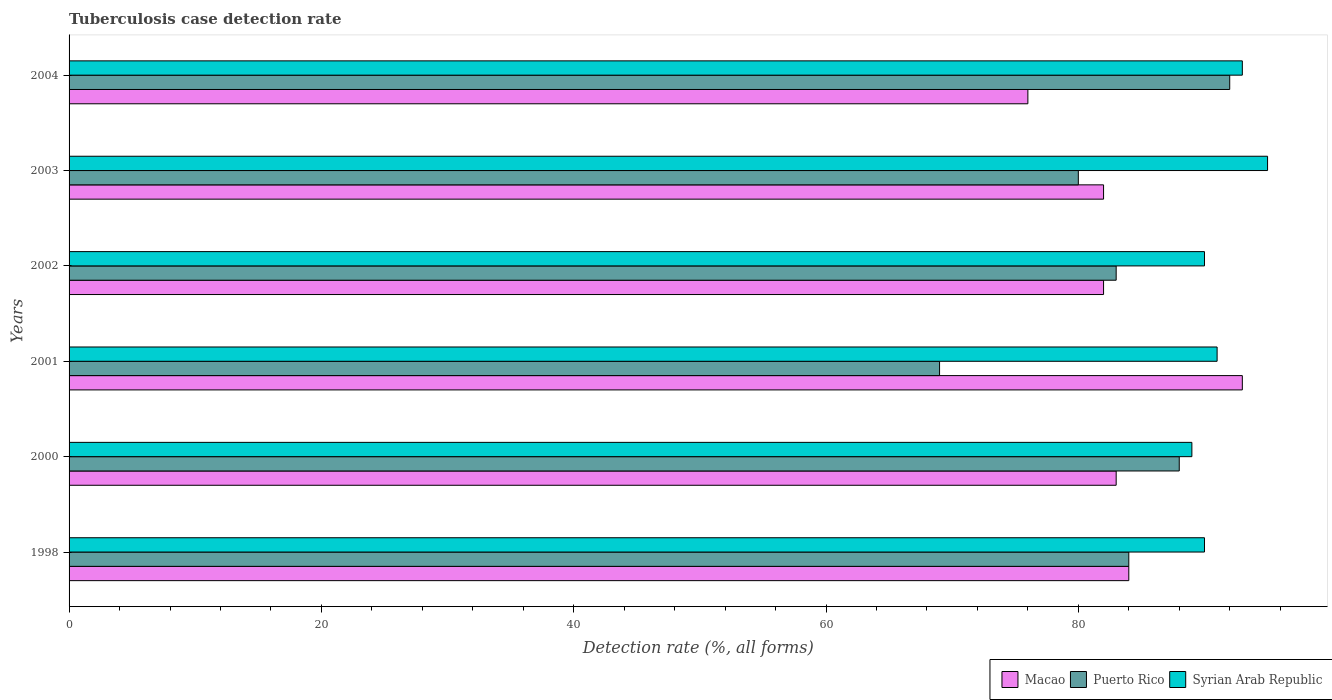How many different coloured bars are there?
Offer a very short reply. 3. How many groups of bars are there?
Give a very brief answer. 6. Are the number of bars per tick equal to the number of legend labels?
Offer a very short reply. Yes. How many bars are there on the 3rd tick from the top?
Your answer should be very brief. 3. In how many cases, is the number of bars for a given year not equal to the number of legend labels?
Your answer should be very brief. 0. What is the tuberculosis case detection rate in in Puerto Rico in 2000?
Your answer should be compact. 88. Across all years, what is the maximum tuberculosis case detection rate in in Macao?
Give a very brief answer. 93. In which year was the tuberculosis case detection rate in in Puerto Rico maximum?
Your answer should be very brief. 2004. In which year was the tuberculosis case detection rate in in Syrian Arab Republic minimum?
Ensure brevity in your answer.  2000. What is the total tuberculosis case detection rate in in Syrian Arab Republic in the graph?
Give a very brief answer. 548. What is the difference between the tuberculosis case detection rate in in Macao in 1998 and that in 2001?
Provide a short and direct response. -9. What is the difference between the tuberculosis case detection rate in in Macao in 2004 and the tuberculosis case detection rate in in Syrian Arab Republic in 2003?
Your answer should be very brief. -19. What is the average tuberculosis case detection rate in in Macao per year?
Provide a short and direct response. 83.33. In the year 2001, what is the difference between the tuberculosis case detection rate in in Puerto Rico and tuberculosis case detection rate in in Macao?
Offer a terse response. -24. What is the ratio of the tuberculosis case detection rate in in Macao in 1998 to that in 2002?
Keep it short and to the point. 1.02. Is the difference between the tuberculosis case detection rate in in Puerto Rico in 2000 and 2004 greater than the difference between the tuberculosis case detection rate in in Macao in 2000 and 2004?
Provide a short and direct response. No. What is the difference between the highest and the lowest tuberculosis case detection rate in in Syrian Arab Republic?
Offer a terse response. 6. What does the 1st bar from the top in 2004 represents?
Offer a terse response. Syrian Arab Republic. What does the 3rd bar from the bottom in 2003 represents?
Your answer should be very brief. Syrian Arab Republic. Are all the bars in the graph horizontal?
Ensure brevity in your answer.  Yes. How many years are there in the graph?
Provide a short and direct response. 6. Where does the legend appear in the graph?
Provide a short and direct response. Bottom right. How many legend labels are there?
Keep it short and to the point. 3. What is the title of the graph?
Provide a succinct answer. Tuberculosis case detection rate. Does "El Salvador" appear as one of the legend labels in the graph?
Ensure brevity in your answer.  No. What is the label or title of the X-axis?
Keep it short and to the point. Detection rate (%, all forms). What is the label or title of the Y-axis?
Make the answer very short. Years. What is the Detection rate (%, all forms) in Syrian Arab Republic in 2000?
Ensure brevity in your answer.  89. What is the Detection rate (%, all forms) of Macao in 2001?
Your answer should be compact. 93. What is the Detection rate (%, all forms) in Syrian Arab Republic in 2001?
Provide a short and direct response. 91. What is the Detection rate (%, all forms) in Syrian Arab Republic in 2002?
Your response must be concise. 90. What is the Detection rate (%, all forms) of Syrian Arab Republic in 2003?
Provide a short and direct response. 95. What is the Detection rate (%, all forms) of Puerto Rico in 2004?
Offer a terse response. 92. What is the Detection rate (%, all forms) of Syrian Arab Republic in 2004?
Ensure brevity in your answer.  93. Across all years, what is the maximum Detection rate (%, all forms) in Macao?
Provide a succinct answer. 93. Across all years, what is the maximum Detection rate (%, all forms) of Puerto Rico?
Keep it short and to the point. 92. Across all years, what is the maximum Detection rate (%, all forms) of Syrian Arab Republic?
Offer a terse response. 95. Across all years, what is the minimum Detection rate (%, all forms) in Syrian Arab Republic?
Your response must be concise. 89. What is the total Detection rate (%, all forms) of Macao in the graph?
Ensure brevity in your answer.  500. What is the total Detection rate (%, all forms) of Puerto Rico in the graph?
Make the answer very short. 496. What is the total Detection rate (%, all forms) of Syrian Arab Republic in the graph?
Provide a succinct answer. 548. What is the difference between the Detection rate (%, all forms) in Macao in 1998 and that in 2000?
Your response must be concise. 1. What is the difference between the Detection rate (%, all forms) in Puerto Rico in 1998 and that in 2000?
Offer a terse response. -4. What is the difference between the Detection rate (%, all forms) in Syrian Arab Republic in 1998 and that in 2000?
Provide a short and direct response. 1. What is the difference between the Detection rate (%, all forms) of Puerto Rico in 1998 and that in 2002?
Offer a terse response. 1. What is the difference between the Detection rate (%, all forms) of Puerto Rico in 1998 and that in 2003?
Make the answer very short. 4. What is the difference between the Detection rate (%, all forms) of Macao in 1998 and that in 2004?
Make the answer very short. 8. What is the difference between the Detection rate (%, all forms) in Syrian Arab Republic in 1998 and that in 2004?
Make the answer very short. -3. What is the difference between the Detection rate (%, all forms) of Macao in 2000 and that in 2001?
Make the answer very short. -10. What is the difference between the Detection rate (%, all forms) of Syrian Arab Republic in 2000 and that in 2001?
Your answer should be compact. -2. What is the difference between the Detection rate (%, all forms) in Macao in 2000 and that in 2002?
Give a very brief answer. 1. What is the difference between the Detection rate (%, all forms) in Puerto Rico in 2000 and that in 2002?
Provide a succinct answer. 5. What is the difference between the Detection rate (%, all forms) of Macao in 2000 and that in 2003?
Offer a very short reply. 1. What is the difference between the Detection rate (%, all forms) in Macao in 2000 and that in 2004?
Make the answer very short. 7. What is the difference between the Detection rate (%, all forms) in Syrian Arab Republic in 2000 and that in 2004?
Make the answer very short. -4. What is the difference between the Detection rate (%, all forms) of Macao in 2001 and that in 2002?
Make the answer very short. 11. What is the difference between the Detection rate (%, all forms) in Puerto Rico in 2001 and that in 2002?
Your answer should be very brief. -14. What is the difference between the Detection rate (%, all forms) of Macao in 2001 and that in 2003?
Ensure brevity in your answer.  11. What is the difference between the Detection rate (%, all forms) in Puerto Rico in 2001 and that in 2003?
Ensure brevity in your answer.  -11. What is the difference between the Detection rate (%, all forms) in Syrian Arab Republic in 2001 and that in 2003?
Make the answer very short. -4. What is the difference between the Detection rate (%, all forms) of Macao in 2001 and that in 2004?
Give a very brief answer. 17. What is the difference between the Detection rate (%, all forms) in Puerto Rico in 2001 and that in 2004?
Your answer should be compact. -23. What is the difference between the Detection rate (%, all forms) in Macao in 2002 and that in 2003?
Give a very brief answer. 0. What is the difference between the Detection rate (%, all forms) in Syrian Arab Republic in 2002 and that in 2003?
Your response must be concise. -5. What is the difference between the Detection rate (%, all forms) in Macao in 2002 and that in 2004?
Your response must be concise. 6. What is the difference between the Detection rate (%, all forms) of Puerto Rico in 2002 and that in 2004?
Make the answer very short. -9. What is the difference between the Detection rate (%, all forms) of Macao in 2003 and that in 2004?
Offer a very short reply. 6. What is the difference between the Detection rate (%, all forms) in Syrian Arab Republic in 2003 and that in 2004?
Your answer should be very brief. 2. What is the difference between the Detection rate (%, all forms) of Macao in 1998 and the Detection rate (%, all forms) of Syrian Arab Republic in 2000?
Your response must be concise. -5. What is the difference between the Detection rate (%, all forms) in Macao in 1998 and the Detection rate (%, all forms) in Puerto Rico in 2001?
Keep it short and to the point. 15. What is the difference between the Detection rate (%, all forms) of Macao in 1998 and the Detection rate (%, all forms) of Syrian Arab Republic in 2001?
Offer a very short reply. -7. What is the difference between the Detection rate (%, all forms) in Puerto Rico in 1998 and the Detection rate (%, all forms) in Syrian Arab Republic in 2001?
Ensure brevity in your answer.  -7. What is the difference between the Detection rate (%, all forms) in Macao in 1998 and the Detection rate (%, all forms) in Syrian Arab Republic in 2002?
Provide a succinct answer. -6. What is the difference between the Detection rate (%, all forms) of Macao in 1998 and the Detection rate (%, all forms) of Puerto Rico in 2003?
Offer a very short reply. 4. What is the difference between the Detection rate (%, all forms) of Macao in 1998 and the Detection rate (%, all forms) of Syrian Arab Republic in 2003?
Offer a very short reply. -11. What is the difference between the Detection rate (%, all forms) of Puerto Rico in 1998 and the Detection rate (%, all forms) of Syrian Arab Republic in 2003?
Your answer should be compact. -11. What is the difference between the Detection rate (%, all forms) in Macao in 1998 and the Detection rate (%, all forms) in Puerto Rico in 2004?
Your answer should be very brief. -8. What is the difference between the Detection rate (%, all forms) of Macao in 1998 and the Detection rate (%, all forms) of Syrian Arab Republic in 2004?
Provide a short and direct response. -9. What is the difference between the Detection rate (%, all forms) in Puerto Rico in 1998 and the Detection rate (%, all forms) in Syrian Arab Republic in 2004?
Offer a very short reply. -9. What is the difference between the Detection rate (%, all forms) in Macao in 2000 and the Detection rate (%, all forms) in Syrian Arab Republic in 2001?
Provide a short and direct response. -8. What is the difference between the Detection rate (%, all forms) in Macao in 2000 and the Detection rate (%, all forms) in Syrian Arab Republic in 2003?
Make the answer very short. -12. What is the difference between the Detection rate (%, all forms) in Macao in 2000 and the Detection rate (%, all forms) in Syrian Arab Republic in 2004?
Offer a terse response. -10. What is the difference between the Detection rate (%, all forms) of Puerto Rico in 2000 and the Detection rate (%, all forms) of Syrian Arab Republic in 2004?
Ensure brevity in your answer.  -5. What is the difference between the Detection rate (%, all forms) in Macao in 2001 and the Detection rate (%, all forms) in Syrian Arab Republic in 2003?
Ensure brevity in your answer.  -2. What is the difference between the Detection rate (%, all forms) in Puerto Rico in 2001 and the Detection rate (%, all forms) in Syrian Arab Republic in 2003?
Provide a succinct answer. -26. What is the difference between the Detection rate (%, all forms) in Macao in 2001 and the Detection rate (%, all forms) in Syrian Arab Republic in 2004?
Provide a short and direct response. 0. What is the difference between the Detection rate (%, all forms) in Macao in 2002 and the Detection rate (%, all forms) in Syrian Arab Republic in 2003?
Offer a terse response. -13. What is the difference between the Detection rate (%, all forms) in Macao in 2002 and the Detection rate (%, all forms) in Puerto Rico in 2004?
Give a very brief answer. -10. What is the difference between the Detection rate (%, all forms) of Macao in 2002 and the Detection rate (%, all forms) of Syrian Arab Republic in 2004?
Offer a terse response. -11. What is the difference between the Detection rate (%, all forms) of Puerto Rico in 2002 and the Detection rate (%, all forms) of Syrian Arab Republic in 2004?
Ensure brevity in your answer.  -10. What is the difference between the Detection rate (%, all forms) of Macao in 2003 and the Detection rate (%, all forms) of Syrian Arab Republic in 2004?
Provide a short and direct response. -11. What is the difference between the Detection rate (%, all forms) of Puerto Rico in 2003 and the Detection rate (%, all forms) of Syrian Arab Republic in 2004?
Give a very brief answer. -13. What is the average Detection rate (%, all forms) in Macao per year?
Provide a succinct answer. 83.33. What is the average Detection rate (%, all forms) of Puerto Rico per year?
Provide a succinct answer. 82.67. What is the average Detection rate (%, all forms) of Syrian Arab Republic per year?
Your answer should be very brief. 91.33. In the year 1998, what is the difference between the Detection rate (%, all forms) in Macao and Detection rate (%, all forms) in Puerto Rico?
Give a very brief answer. 0. In the year 1998, what is the difference between the Detection rate (%, all forms) of Macao and Detection rate (%, all forms) of Syrian Arab Republic?
Your answer should be very brief. -6. In the year 1998, what is the difference between the Detection rate (%, all forms) in Puerto Rico and Detection rate (%, all forms) in Syrian Arab Republic?
Your answer should be very brief. -6. In the year 2000, what is the difference between the Detection rate (%, all forms) in Macao and Detection rate (%, all forms) in Puerto Rico?
Your answer should be compact. -5. In the year 2000, what is the difference between the Detection rate (%, all forms) of Macao and Detection rate (%, all forms) of Syrian Arab Republic?
Your response must be concise. -6. In the year 2002, what is the difference between the Detection rate (%, all forms) of Puerto Rico and Detection rate (%, all forms) of Syrian Arab Republic?
Provide a succinct answer. -7. In the year 2003, what is the difference between the Detection rate (%, all forms) of Macao and Detection rate (%, all forms) of Syrian Arab Republic?
Provide a succinct answer. -13. In the year 2004, what is the difference between the Detection rate (%, all forms) in Macao and Detection rate (%, all forms) in Puerto Rico?
Provide a short and direct response. -16. In the year 2004, what is the difference between the Detection rate (%, all forms) in Macao and Detection rate (%, all forms) in Syrian Arab Republic?
Ensure brevity in your answer.  -17. In the year 2004, what is the difference between the Detection rate (%, all forms) of Puerto Rico and Detection rate (%, all forms) of Syrian Arab Republic?
Your answer should be compact. -1. What is the ratio of the Detection rate (%, all forms) in Macao in 1998 to that in 2000?
Your answer should be very brief. 1.01. What is the ratio of the Detection rate (%, all forms) in Puerto Rico in 1998 to that in 2000?
Give a very brief answer. 0.95. What is the ratio of the Detection rate (%, all forms) of Syrian Arab Republic in 1998 to that in 2000?
Your answer should be very brief. 1.01. What is the ratio of the Detection rate (%, all forms) in Macao in 1998 to that in 2001?
Make the answer very short. 0.9. What is the ratio of the Detection rate (%, all forms) in Puerto Rico in 1998 to that in 2001?
Your response must be concise. 1.22. What is the ratio of the Detection rate (%, all forms) in Macao in 1998 to that in 2002?
Make the answer very short. 1.02. What is the ratio of the Detection rate (%, all forms) of Macao in 1998 to that in 2003?
Provide a succinct answer. 1.02. What is the ratio of the Detection rate (%, all forms) in Puerto Rico in 1998 to that in 2003?
Offer a very short reply. 1.05. What is the ratio of the Detection rate (%, all forms) of Syrian Arab Republic in 1998 to that in 2003?
Your answer should be very brief. 0.95. What is the ratio of the Detection rate (%, all forms) in Macao in 1998 to that in 2004?
Your answer should be compact. 1.11. What is the ratio of the Detection rate (%, all forms) of Syrian Arab Republic in 1998 to that in 2004?
Your response must be concise. 0.97. What is the ratio of the Detection rate (%, all forms) in Macao in 2000 to that in 2001?
Provide a succinct answer. 0.89. What is the ratio of the Detection rate (%, all forms) of Puerto Rico in 2000 to that in 2001?
Your answer should be very brief. 1.28. What is the ratio of the Detection rate (%, all forms) in Syrian Arab Republic in 2000 to that in 2001?
Your answer should be compact. 0.98. What is the ratio of the Detection rate (%, all forms) of Macao in 2000 to that in 2002?
Offer a very short reply. 1.01. What is the ratio of the Detection rate (%, all forms) in Puerto Rico in 2000 to that in 2002?
Make the answer very short. 1.06. What is the ratio of the Detection rate (%, all forms) of Syrian Arab Republic in 2000 to that in 2002?
Give a very brief answer. 0.99. What is the ratio of the Detection rate (%, all forms) in Macao in 2000 to that in 2003?
Provide a succinct answer. 1.01. What is the ratio of the Detection rate (%, all forms) of Puerto Rico in 2000 to that in 2003?
Make the answer very short. 1.1. What is the ratio of the Detection rate (%, all forms) of Syrian Arab Republic in 2000 to that in 2003?
Provide a succinct answer. 0.94. What is the ratio of the Detection rate (%, all forms) of Macao in 2000 to that in 2004?
Provide a succinct answer. 1.09. What is the ratio of the Detection rate (%, all forms) in Puerto Rico in 2000 to that in 2004?
Provide a succinct answer. 0.96. What is the ratio of the Detection rate (%, all forms) of Macao in 2001 to that in 2002?
Your response must be concise. 1.13. What is the ratio of the Detection rate (%, all forms) in Puerto Rico in 2001 to that in 2002?
Your response must be concise. 0.83. What is the ratio of the Detection rate (%, all forms) of Syrian Arab Republic in 2001 to that in 2002?
Ensure brevity in your answer.  1.01. What is the ratio of the Detection rate (%, all forms) in Macao in 2001 to that in 2003?
Provide a succinct answer. 1.13. What is the ratio of the Detection rate (%, all forms) in Puerto Rico in 2001 to that in 2003?
Your response must be concise. 0.86. What is the ratio of the Detection rate (%, all forms) of Syrian Arab Republic in 2001 to that in 2003?
Make the answer very short. 0.96. What is the ratio of the Detection rate (%, all forms) in Macao in 2001 to that in 2004?
Give a very brief answer. 1.22. What is the ratio of the Detection rate (%, all forms) in Puerto Rico in 2001 to that in 2004?
Give a very brief answer. 0.75. What is the ratio of the Detection rate (%, all forms) of Syrian Arab Republic in 2001 to that in 2004?
Offer a very short reply. 0.98. What is the ratio of the Detection rate (%, all forms) in Macao in 2002 to that in 2003?
Keep it short and to the point. 1. What is the ratio of the Detection rate (%, all forms) of Puerto Rico in 2002 to that in 2003?
Ensure brevity in your answer.  1.04. What is the ratio of the Detection rate (%, all forms) of Macao in 2002 to that in 2004?
Your answer should be very brief. 1.08. What is the ratio of the Detection rate (%, all forms) in Puerto Rico in 2002 to that in 2004?
Your response must be concise. 0.9. What is the ratio of the Detection rate (%, all forms) of Syrian Arab Republic in 2002 to that in 2004?
Your response must be concise. 0.97. What is the ratio of the Detection rate (%, all forms) of Macao in 2003 to that in 2004?
Offer a very short reply. 1.08. What is the ratio of the Detection rate (%, all forms) in Puerto Rico in 2003 to that in 2004?
Keep it short and to the point. 0.87. What is the ratio of the Detection rate (%, all forms) of Syrian Arab Republic in 2003 to that in 2004?
Your answer should be very brief. 1.02. What is the difference between the highest and the second highest Detection rate (%, all forms) in Macao?
Offer a terse response. 9. What is the difference between the highest and the lowest Detection rate (%, all forms) of Macao?
Your response must be concise. 17. What is the difference between the highest and the lowest Detection rate (%, all forms) in Puerto Rico?
Ensure brevity in your answer.  23. 